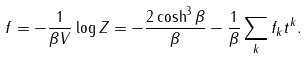Convert formula to latex. <formula><loc_0><loc_0><loc_500><loc_500>f = - \frac { 1 } { \beta V } \log { Z } = - \frac { 2 \cosh ^ { 3 } { \beta } } { \beta } - \frac { 1 } { \beta } \sum _ { k } f _ { k } t ^ { k } .</formula> 